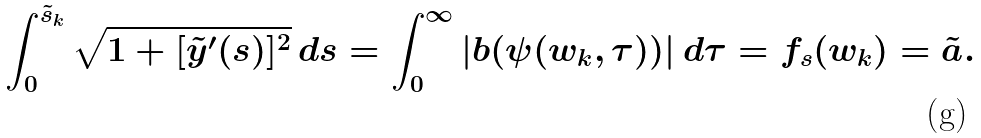Convert formula to latex. <formula><loc_0><loc_0><loc_500><loc_500>\int _ { 0 } ^ { \tilde { s } _ { k } } \sqrt { 1 + [ \tilde { y } ^ { \prime } ( s ) ] ^ { 2 } } \, d s = \int ^ { \infty } _ { 0 } | b ( \psi ( w _ { k } , \tau ) ) | \, d \tau = f _ { s } ( w _ { k } ) = \tilde { a } .</formula> 